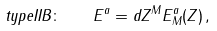<formula> <loc_0><loc_0><loc_500><loc_500>t y p e I I B \colon \quad E ^ { a } = d Z ^ { M } E _ { M } ^ { a } ( Z ) \, ,</formula> 